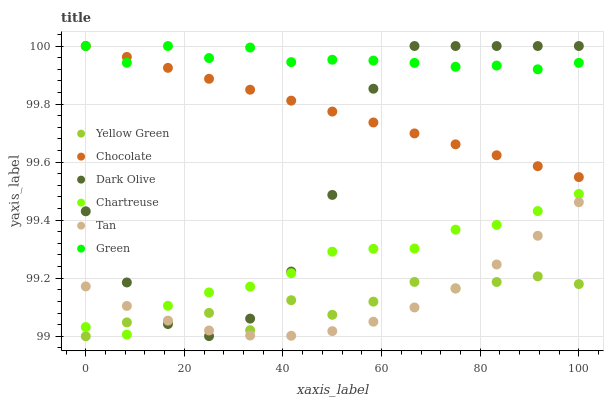Does Yellow Green have the minimum area under the curve?
Answer yes or no. Yes. Does Green have the maximum area under the curve?
Answer yes or no. Yes. Does Dark Olive have the minimum area under the curve?
Answer yes or no. No. Does Dark Olive have the maximum area under the curve?
Answer yes or no. No. Is Chocolate the smoothest?
Answer yes or no. Yes. Is Dark Olive the roughest?
Answer yes or no. Yes. Is Dark Olive the smoothest?
Answer yes or no. No. Is Chocolate the roughest?
Answer yes or no. No. Does Yellow Green have the lowest value?
Answer yes or no. Yes. Does Dark Olive have the lowest value?
Answer yes or no. No. Does Green have the highest value?
Answer yes or no. Yes. Does Chartreuse have the highest value?
Answer yes or no. No. Is Tan less than Green?
Answer yes or no. Yes. Is Green greater than Tan?
Answer yes or no. Yes. Does Tan intersect Yellow Green?
Answer yes or no. Yes. Is Tan less than Yellow Green?
Answer yes or no. No. Is Tan greater than Yellow Green?
Answer yes or no. No. Does Tan intersect Green?
Answer yes or no. No. 